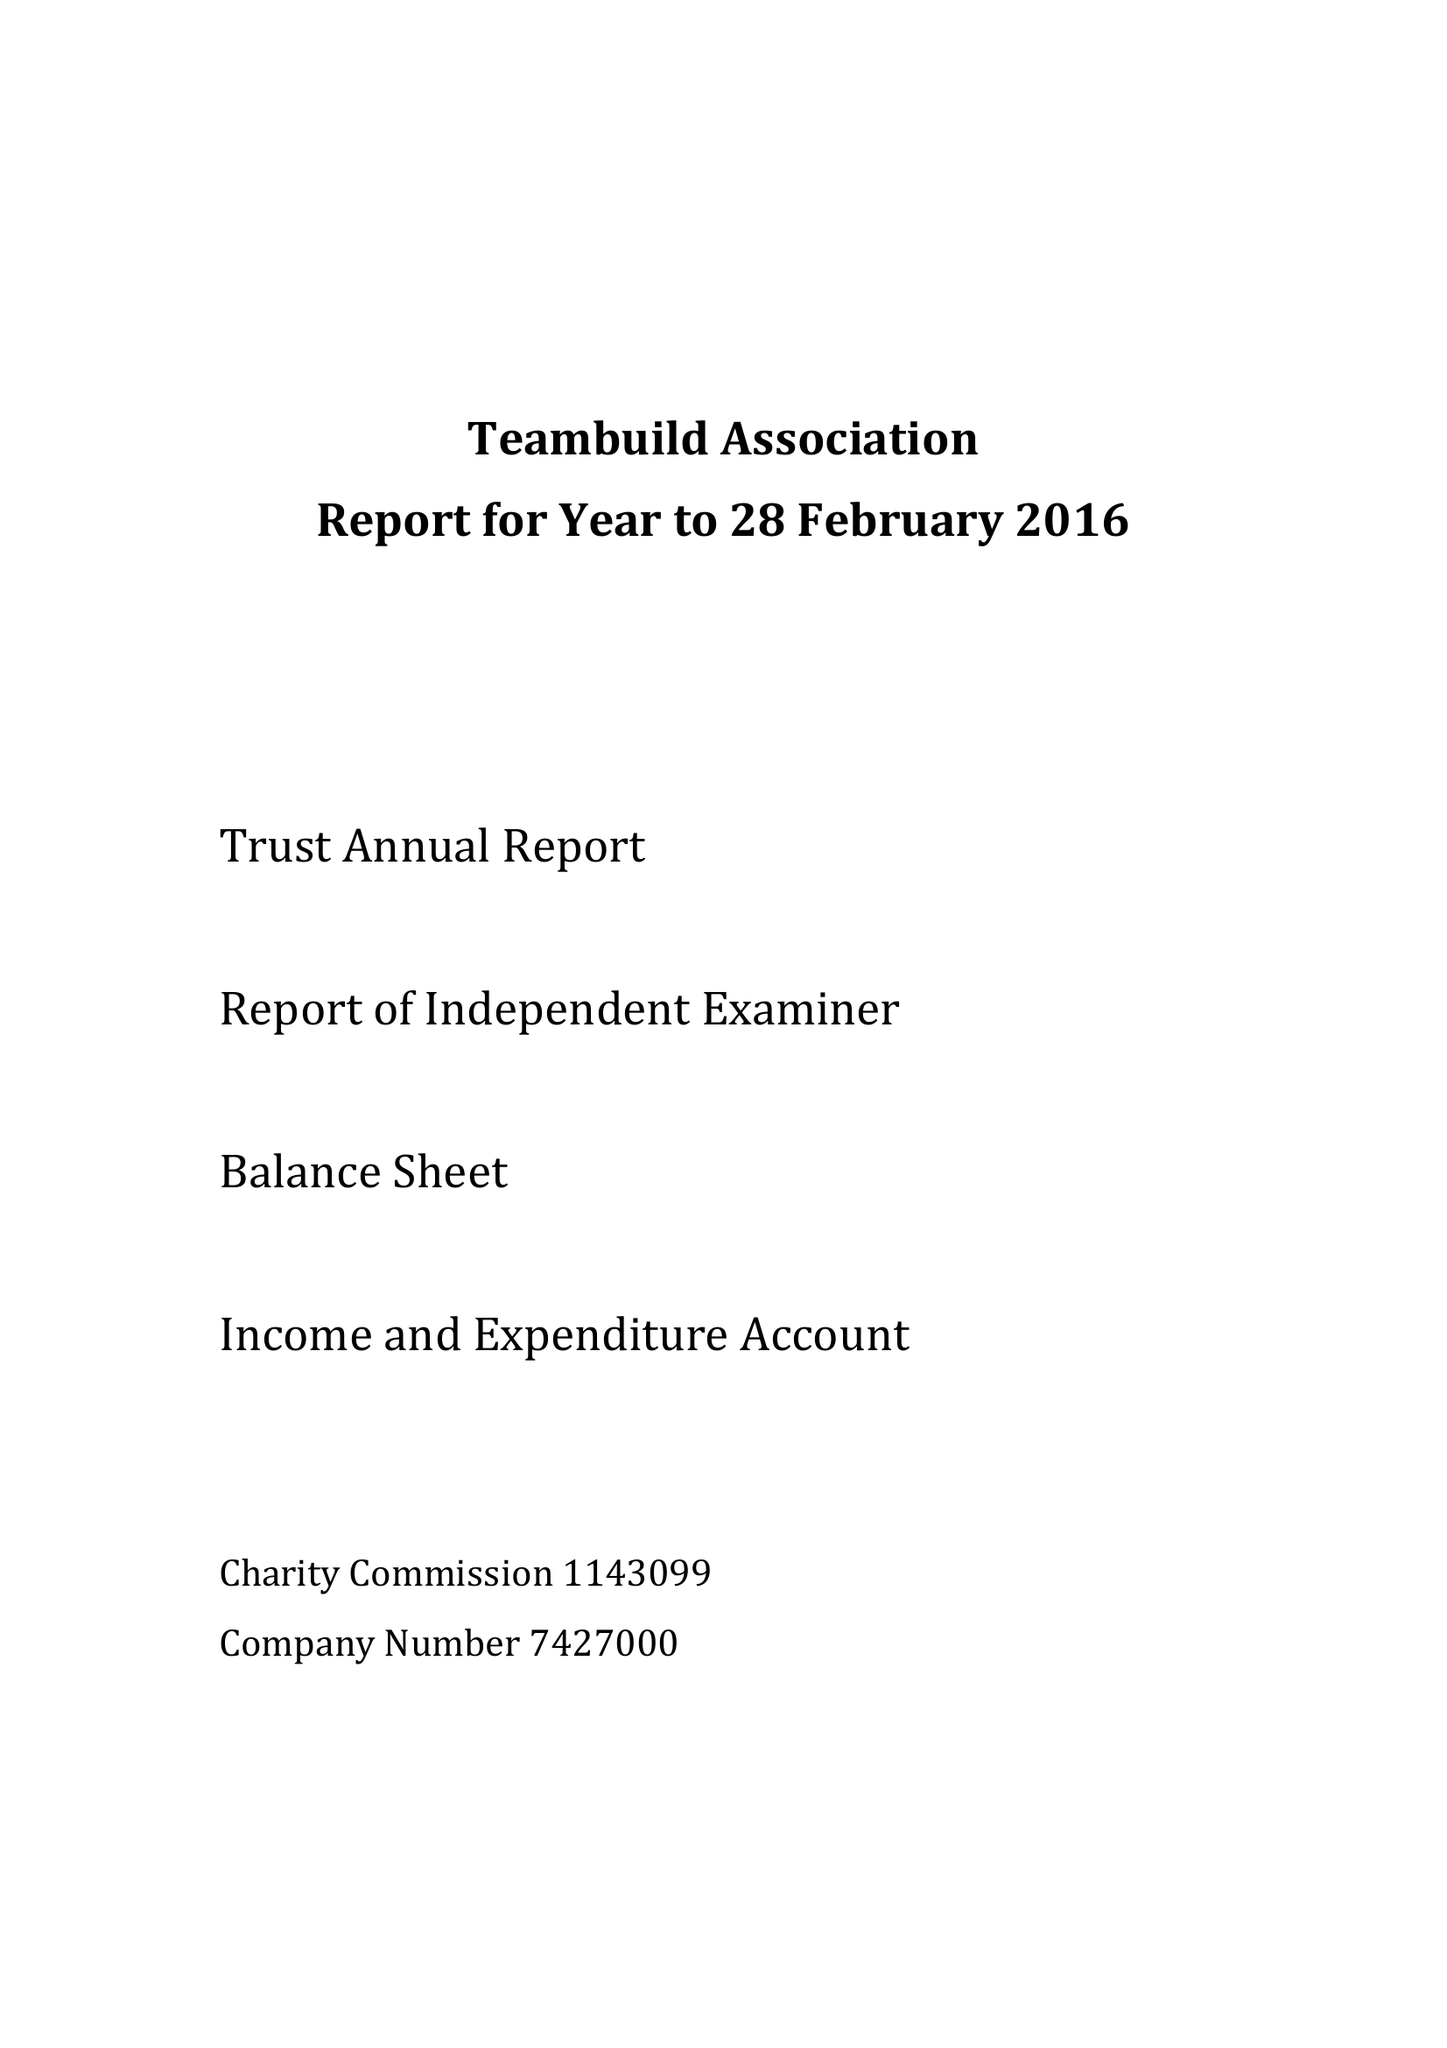What is the value for the address__postcode?
Answer the question using a single word or phrase. SL2 4PB 